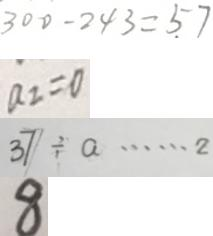Convert formula to latex. <formula><loc_0><loc_0><loc_500><loc_500>3 0 0 - 2 4 3 = 5 7 
 a _ { 2 } = 0 
 3 7 \div a \cdots 2 
 8</formula> 